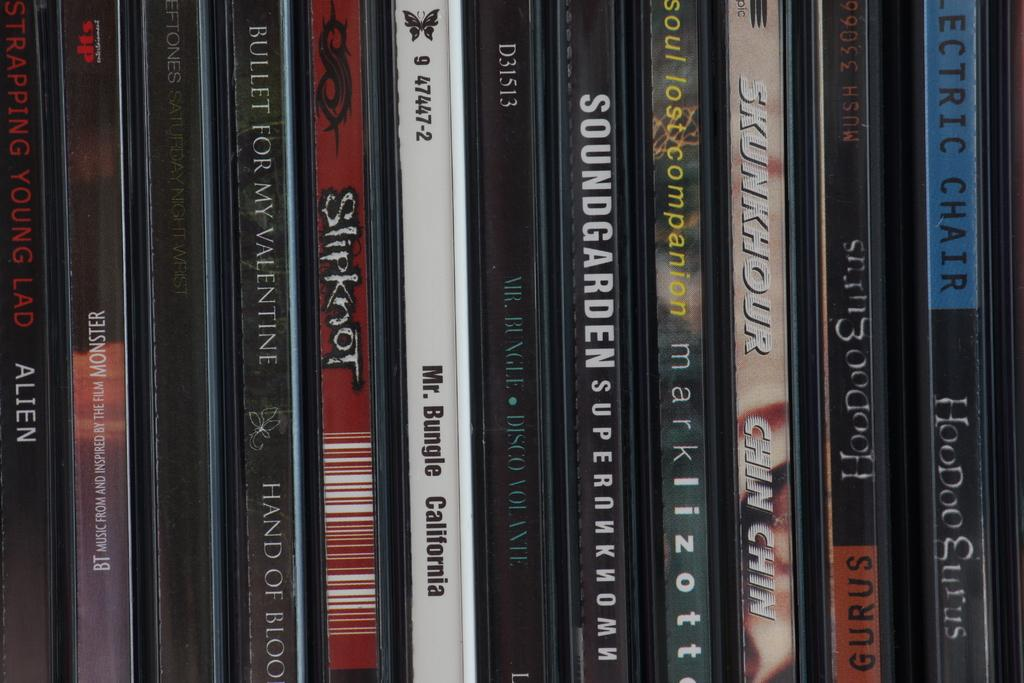Provide a one-sentence caption for the provided image. A row of compact discs include alternative bands like Mr Bungle, Bullet for My Valentine and Strapping Young Lad. 